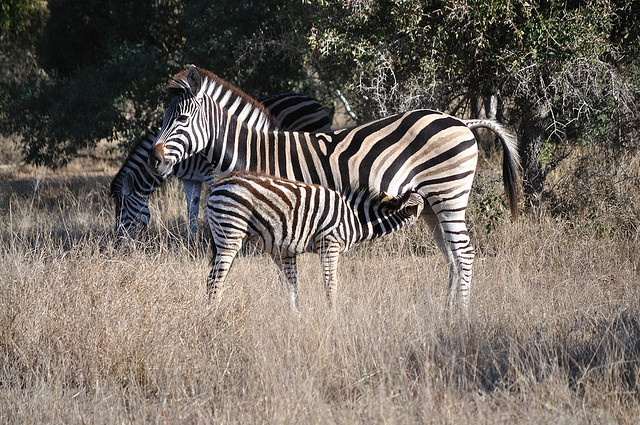Describe the objects in this image and their specific colors. I can see zebra in darkgreen, black, white, gray, and darkgray tones, zebra in darkgreen, black, lightgray, darkgray, and gray tones, zebra in darkgreen, black, gray, and darkgray tones, and zebra in darkgreen, black, and gray tones in this image. 